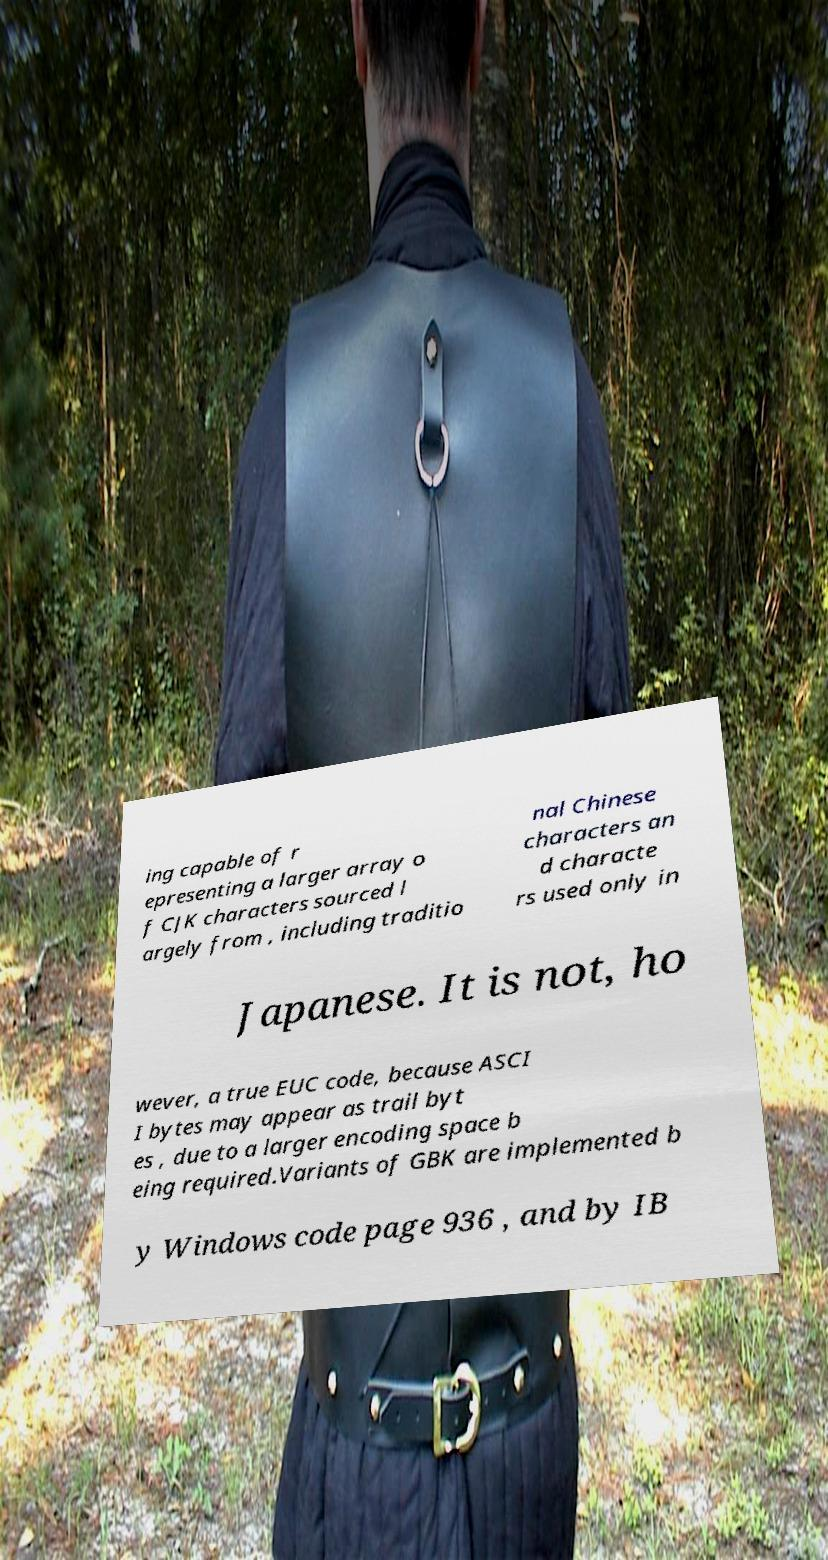Can you read and provide the text displayed in the image?This photo seems to have some interesting text. Can you extract and type it out for me? ing capable of r epresenting a larger array o f CJK characters sourced l argely from , including traditio nal Chinese characters an d characte rs used only in Japanese. It is not, ho wever, a true EUC code, because ASCI I bytes may appear as trail byt es , due to a larger encoding space b eing required.Variants of GBK are implemented b y Windows code page 936 , and by IB 